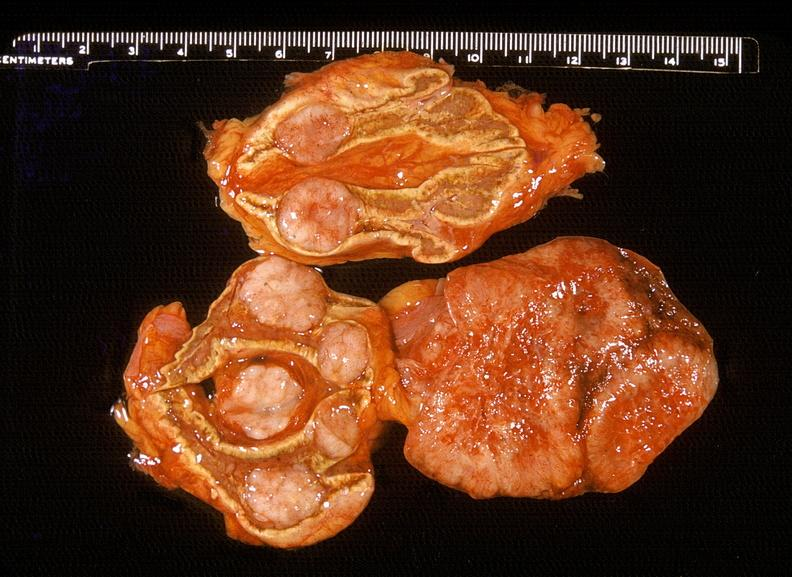where does this belong to?
Answer the question using a single word or phrase. Endocrine system 